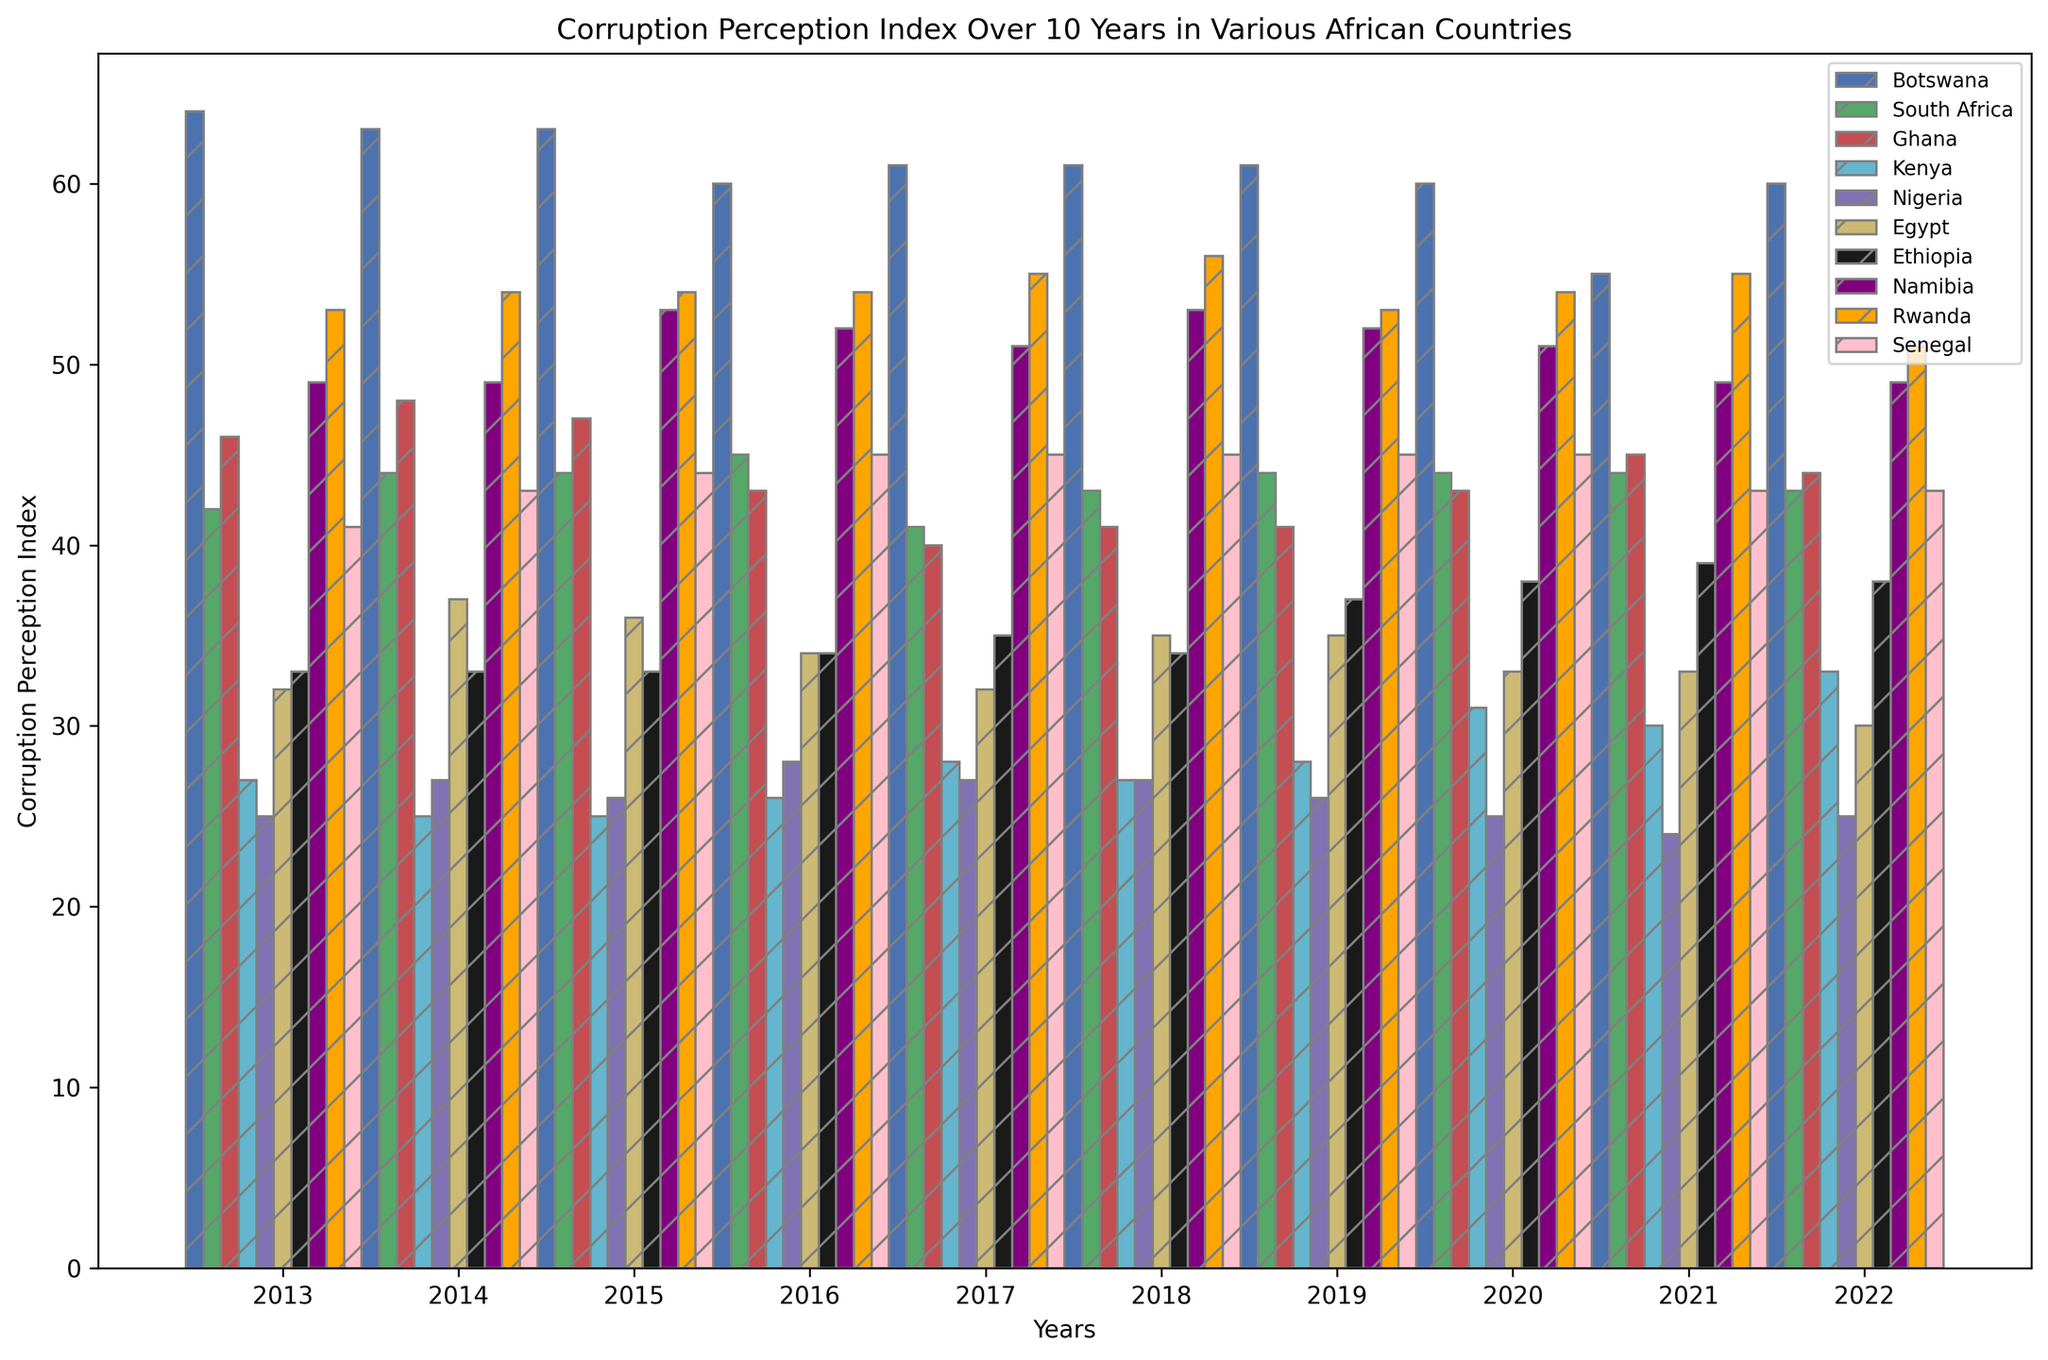What is the highest Corruption Perception Index (CPI) score for Botswana? Look at the bars for Botswana, which are blue and have a hatch pattern. The highest bar appears in 2013 which reaches up to the value of 64.
Answer: 64 Which country had the lowest CPI score throughout the period? Compare the lowest bars of each country. Nigeria's bars are consistently the lowest, with the lowest value being 24 in 2021.
Answer: Nigeria What is the difference in CPI scores between South Africa and Ghana in 2022? Find the bars for South Africa (turquoise) and Ghana (red) in 2022. Subtract Ghana's score (44) from South Africa's score (43), which results in a difference of -1.
Answer: -1 How did Kenya's CPI score change from 2016 to 2020? Locate the bars for Kenya (orange) in 2016 and 2020. The scores are 26 (2016) and 31 (2020). Subtract 26 from 31 to find the change, which is 5.
Answer: +5 Which country showed the most significant decline in CPI score from 2013 to 2022? Review the first and last bars for each country, evaluating the decline. Botswana's score decreased from 64 in 2013 to 60 in 2022, resulting in the most significant decline of 4 points.
Answer: Botswana What's the average CPI score for Rwanda between 2013 and 2022? Add up all values for Rwanda from 2013 to 2022 (53, 54, 54, 54, 55, 56, 53, 54, 55, 51), which sum up to 539, then divide by 10 (years) to get the average: 539/10 = 53.9.
Answer: 53.9 Compare the CPI scores of Ethiopia and Egypt in 2021. Which is higher and by how much? Find the bars for Ethiopia (green with hatch) and Egypt (pink with hatch) in 2021. Ethiopia's score is 39, Egypt's score is 33. Subtract Egypt's score from Ethiopia's to find the difference: 39 - 33 = 6.
Answer: Ethiopia, by 6 How do Namibia's and Senegal's CPI scores in 2017 compare to each other? Compare the bars in 2017 for Namibia (yellow) and Senegal (brown). Both have the same score of 45.
Answer: They are equal What is the median CPI score for Kenya from 2013 to 2022? List Kenya's CPI scores: 27, 25, 25, 26, 28, 27, 28, 31, 30, 33. Arrange them in ascending order: 25, 25, 26, 27, 27, 28, 28, 30, 31, 33. The median is the average of the 5th and 6th value: (27 + 28)/2 = 27.5
Answer: 27.5 For which year did South Africa have the highest CPI score in the given period? Observe the bars for South Africa (c) and identify the highest bar. The highest score, 45, occurs in 2016.
Answer: 2016 